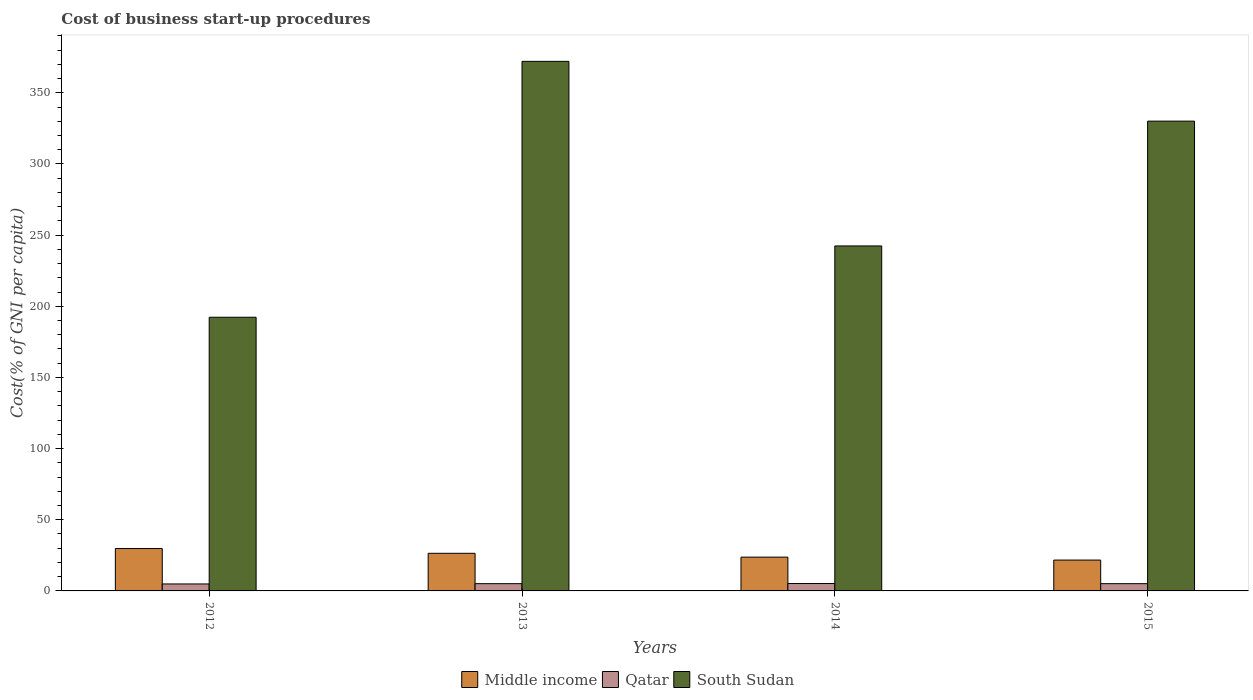How many groups of bars are there?
Your answer should be compact. 4. Are the number of bars per tick equal to the number of legend labels?
Your answer should be compact. Yes. Are the number of bars on each tick of the X-axis equal?
Your response must be concise. Yes. How many bars are there on the 3rd tick from the right?
Your answer should be compact. 3. What is the label of the 4th group of bars from the left?
Ensure brevity in your answer.  2015. In how many cases, is the number of bars for a given year not equal to the number of legend labels?
Offer a terse response. 0. What is the cost of business start-up procedures in South Sudan in 2013?
Provide a succinct answer. 372.1. Across all years, what is the maximum cost of business start-up procedures in Middle income?
Your answer should be very brief. 29.78. Across all years, what is the minimum cost of business start-up procedures in Qatar?
Give a very brief answer. 4.9. In which year was the cost of business start-up procedures in Middle income minimum?
Make the answer very short. 2015. What is the total cost of business start-up procedures in Qatar in the graph?
Keep it short and to the point. 20.3. What is the difference between the cost of business start-up procedures in South Sudan in 2012 and that in 2015?
Provide a short and direct response. -137.8. What is the difference between the cost of business start-up procedures in Qatar in 2015 and the cost of business start-up procedures in Middle income in 2012?
Provide a succinct answer. -24.68. What is the average cost of business start-up procedures in Middle income per year?
Give a very brief answer. 25.41. In the year 2012, what is the difference between the cost of business start-up procedures in Middle income and cost of business start-up procedures in Qatar?
Offer a terse response. 24.88. What is the ratio of the cost of business start-up procedures in South Sudan in 2013 to that in 2014?
Your answer should be very brief. 1.54. Is the cost of business start-up procedures in South Sudan in 2012 less than that in 2015?
Your answer should be very brief. Yes. What is the difference between the highest and the second highest cost of business start-up procedures in South Sudan?
Your response must be concise. 42. What is the difference between the highest and the lowest cost of business start-up procedures in South Sudan?
Offer a terse response. 179.8. In how many years, is the cost of business start-up procedures in Qatar greater than the average cost of business start-up procedures in Qatar taken over all years?
Give a very brief answer. 3. Is the sum of the cost of business start-up procedures in Middle income in 2012 and 2013 greater than the maximum cost of business start-up procedures in South Sudan across all years?
Make the answer very short. No. What does the 1st bar from the left in 2014 represents?
Offer a terse response. Middle income. What does the 1st bar from the right in 2015 represents?
Give a very brief answer. South Sudan. Are all the bars in the graph horizontal?
Your answer should be very brief. No. How many years are there in the graph?
Offer a terse response. 4. Are the values on the major ticks of Y-axis written in scientific E-notation?
Your answer should be very brief. No. Does the graph contain any zero values?
Make the answer very short. No. Does the graph contain grids?
Keep it short and to the point. No. How are the legend labels stacked?
Provide a succinct answer. Horizontal. What is the title of the graph?
Provide a short and direct response. Cost of business start-up procedures. What is the label or title of the X-axis?
Keep it short and to the point. Years. What is the label or title of the Y-axis?
Ensure brevity in your answer.  Cost(% of GNI per capita). What is the Cost(% of GNI per capita) in Middle income in 2012?
Ensure brevity in your answer.  29.78. What is the Cost(% of GNI per capita) of Qatar in 2012?
Offer a terse response. 4.9. What is the Cost(% of GNI per capita) of South Sudan in 2012?
Offer a very short reply. 192.3. What is the Cost(% of GNI per capita) in Middle income in 2013?
Ensure brevity in your answer.  26.43. What is the Cost(% of GNI per capita) in South Sudan in 2013?
Provide a succinct answer. 372.1. What is the Cost(% of GNI per capita) in Middle income in 2014?
Keep it short and to the point. 23.74. What is the Cost(% of GNI per capita) of South Sudan in 2014?
Offer a terse response. 242.4. What is the Cost(% of GNI per capita) in Middle income in 2015?
Ensure brevity in your answer.  21.68. What is the Cost(% of GNI per capita) of Qatar in 2015?
Your answer should be compact. 5.1. What is the Cost(% of GNI per capita) in South Sudan in 2015?
Provide a succinct answer. 330.1. Across all years, what is the maximum Cost(% of GNI per capita) of Middle income?
Offer a terse response. 29.78. Across all years, what is the maximum Cost(% of GNI per capita) in South Sudan?
Provide a short and direct response. 372.1. Across all years, what is the minimum Cost(% of GNI per capita) in Middle income?
Your response must be concise. 21.68. Across all years, what is the minimum Cost(% of GNI per capita) of Qatar?
Provide a short and direct response. 4.9. Across all years, what is the minimum Cost(% of GNI per capita) of South Sudan?
Offer a very short reply. 192.3. What is the total Cost(% of GNI per capita) in Middle income in the graph?
Your response must be concise. 101.62. What is the total Cost(% of GNI per capita) of Qatar in the graph?
Your answer should be compact. 20.3. What is the total Cost(% of GNI per capita) in South Sudan in the graph?
Provide a succinct answer. 1136.9. What is the difference between the Cost(% of GNI per capita) of Middle income in 2012 and that in 2013?
Your answer should be very brief. 3.36. What is the difference between the Cost(% of GNI per capita) in Qatar in 2012 and that in 2013?
Give a very brief answer. -0.2. What is the difference between the Cost(% of GNI per capita) of South Sudan in 2012 and that in 2013?
Your response must be concise. -179.8. What is the difference between the Cost(% of GNI per capita) in Middle income in 2012 and that in 2014?
Provide a succinct answer. 6.04. What is the difference between the Cost(% of GNI per capita) in Qatar in 2012 and that in 2014?
Offer a very short reply. -0.3. What is the difference between the Cost(% of GNI per capita) of South Sudan in 2012 and that in 2014?
Your response must be concise. -50.1. What is the difference between the Cost(% of GNI per capita) in Middle income in 2012 and that in 2015?
Make the answer very short. 8.11. What is the difference between the Cost(% of GNI per capita) in Qatar in 2012 and that in 2015?
Your response must be concise. -0.2. What is the difference between the Cost(% of GNI per capita) of South Sudan in 2012 and that in 2015?
Make the answer very short. -137.8. What is the difference between the Cost(% of GNI per capita) in Middle income in 2013 and that in 2014?
Ensure brevity in your answer.  2.69. What is the difference between the Cost(% of GNI per capita) in Qatar in 2013 and that in 2014?
Your answer should be very brief. -0.1. What is the difference between the Cost(% of GNI per capita) in South Sudan in 2013 and that in 2014?
Your answer should be compact. 129.7. What is the difference between the Cost(% of GNI per capita) of Middle income in 2013 and that in 2015?
Your answer should be compact. 4.75. What is the difference between the Cost(% of GNI per capita) of Qatar in 2013 and that in 2015?
Your response must be concise. 0. What is the difference between the Cost(% of GNI per capita) in South Sudan in 2013 and that in 2015?
Offer a terse response. 42. What is the difference between the Cost(% of GNI per capita) of Middle income in 2014 and that in 2015?
Your response must be concise. 2.06. What is the difference between the Cost(% of GNI per capita) of Qatar in 2014 and that in 2015?
Offer a very short reply. 0.1. What is the difference between the Cost(% of GNI per capita) of South Sudan in 2014 and that in 2015?
Make the answer very short. -87.7. What is the difference between the Cost(% of GNI per capita) in Middle income in 2012 and the Cost(% of GNI per capita) in Qatar in 2013?
Give a very brief answer. 24.68. What is the difference between the Cost(% of GNI per capita) in Middle income in 2012 and the Cost(% of GNI per capita) in South Sudan in 2013?
Your answer should be compact. -342.32. What is the difference between the Cost(% of GNI per capita) in Qatar in 2012 and the Cost(% of GNI per capita) in South Sudan in 2013?
Give a very brief answer. -367.2. What is the difference between the Cost(% of GNI per capita) of Middle income in 2012 and the Cost(% of GNI per capita) of Qatar in 2014?
Provide a succinct answer. 24.58. What is the difference between the Cost(% of GNI per capita) in Middle income in 2012 and the Cost(% of GNI per capita) in South Sudan in 2014?
Provide a succinct answer. -212.62. What is the difference between the Cost(% of GNI per capita) of Qatar in 2012 and the Cost(% of GNI per capita) of South Sudan in 2014?
Give a very brief answer. -237.5. What is the difference between the Cost(% of GNI per capita) of Middle income in 2012 and the Cost(% of GNI per capita) of Qatar in 2015?
Offer a very short reply. 24.68. What is the difference between the Cost(% of GNI per capita) of Middle income in 2012 and the Cost(% of GNI per capita) of South Sudan in 2015?
Provide a short and direct response. -300.32. What is the difference between the Cost(% of GNI per capita) in Qatar in 2012 and the Cost(% of GNI per capita) in South Sudan in 2015?
Offer a very short reply. -325.2. What is the difference between the Cost(% of GNI per capita) of Middle income in 2013 and the Cost(% of GNI per capita) of Qatar in 2014?
Your answer should be compact. 21.23. What is the difference between the Cost(% of GNI per capita) of Middle income in 2013 and the Cost(% of GNI per capita) of South Sudan in 2014?
Offer a terse response. -215.97. What is the difference between the Cost(% of GNI per capita) in Qatar in 2013 and the Cost(% of GNI per capita) in South Sudan in 2014?
Make the answer very short. -237.3. What is the difference between the Cost(% of GNI per capita) in Middle income in 2013 and the Cost(% of GNI per capita) in Qatar in 2015?
Make the answer very short. 21.33. What is the difference between the Cost(% of GNI per capita) in Middle income in 2013 and the Cost(% of GNI per capita) in South Sudan in 2015?
Make the answer very short. -303.67. What is the difference between the Cost(% of GNI per capita) in Qatar in 2013 and the Cost(% of GNI per capita) in South Sudan in 2015?
Provide a succinct answer. -325. What is the difference between the Cost(% of GNI per capita) in Middle income in 2014 and the Cost(% of GNI per capita) in Qatar in 2015?
Your answer should be compact. 18.64. What is the difference between the Cost(% of GNI per capita) of Middle income in 2014 and the Cost(% of GNI per capita) of South Sudan in 2015?
Your answer should be compact. -306.36. What is the difference between the Cost(% of GNI per capita) of Qatar in 2014 and the Cost(% of GNI per capita) of South Sudan in 2015?
Offer a terse response. -324.9. What is the average Cost(% of GNI per capita) in Middle income per year?
Keep it short and to the point. 25.41. What is the average Cost(% of GNI per capita) in Qatar per year?
Your answer should be very brief. 5.08. What is the average Cost(% of GNI per capita) in South Sudan per year?
Provide a short and direct response. 284.23. In the year 2012, what is the difference between the Cost(% of GNI per capita) in Middle income and Cost(% of GNI per capita) in Qatar?
Offer a terse response. 24.88. In the year 2012, what is the difference between the Cost(% of GNI per capita) in Middle income and Cost(% of GNI per capita) in South Sudan?
Ensure brevity in your answer.  -162.52. In the year 2012, what is the difference between the Cost(% of GNI per capita) in Qatar and Cost(% of GNI per capita) in South Sudan?
Offer a very short reply. -187.4. In the year 2013, what is the difference between the Cost(% of GNI per capita) in Middle income and Cost(% of GNI per capita) in Qatar?
Keep it short and to the point. 21.33. In the year 2013, what is the difference between the Cost(% of GNI per capita) in Middle income and Cost(% of GNI per capita) in South Sudan?
Offer a terse response. -345.67. In the year 2013, what is the difference between the Cost(% of GNI per capita) of Qatar and Cost(% of GNI per capita) of South Sudan?
Make the answer very short. -367. In the year 2014, what is the difference between the Cost(% of GNI per capita) in Middle income and Cost(% of GNI per capita) in Qatar?
Keep it short and to the point. 18.54. In the year 2014, what is the difference between the Cost(% of GNI per capita) of Middle income and Cost(% of GNI per capita) of South Sudan?
Your answer should be compact. -218.66. In the year 2014, what is the difference between the Cost(% of GNI per capita) in Qatar and Cost(% of GNI per capita) in South Sudan?
Your answer should be compact. -237.2. In the year 2015, what is the difference between the Cost(% of GNI per capita) of Middle income and Cost(% of GNI per capita) of Qatar?
Make the answer very short. 16.58. In the year 2015, what is the difference between the Cost(% of GNI per capita) of Middle income and Cost(% of GNI per capita) of South Sudan?
Make the answer very short. -308.42. In the year 2015, what is the difference between the Cost(% of GNI per capita) of Qatar and Cost(% of GNI per capita) of South Sudan?
Give a very brief answer. -325. What is the ratio of the Cost(% of GNI per capita) of Middle income in 2012 to that in 2013?
Provide a short and direct response. 1.13. What is the ratio of the Cost(% of GNI per capita) in Qatar in 2012 to that in 2013?
Your answer should be very brief. 0.96. What is the ratio of the Cost(% of GNI per capita) in South Sudan in 2012 to that in 2013?
Make the answer very short. 0.52. What is the ratio of the Cost(% of GNI per capita) in Middle income in 2012 to that in 2014?
Your answer should be compact. 1.25. What is the ratio of the Cost(% of GNI per capita) of Qatar in 2012 to that in 2014?
Offer a very short reply. 0.94. What is the ratio of the Cost(% of GNI per capita) of South Sudan in 2012 to that in 2014?
Keep it short and to the point. 0.79. What is the ratio of the Cost(% of GNI per capita) of Middle income in 2012 to that in 2015?
Your answer should be very brief. 1.37. What is the ratio of the Cost(% of GNI per capita) of Qatar in 2012 to that in 2015?
Provide a short and direct response. 0.96. What is the ratio of the Cost(% of GNI per capita) in South Sudan in 2012 to that in 2015?
Make the answer very short. 0.58. What is the ratio of the Cost(% of GNI per capita) in Middle income in 2013 to that in 2014?
Provide a succinct answer. 1.11. What is the ratio of the Cost(% of GNI per capita) in Qatar in 2013 to that in 2014?
Make the answer very short. 0.98. What is the ratio of the Cost(% of GNI per capita) in South Sudan in 2013 to that in 2014?
Offer a very short reply. 1.54. What is the ratio of the Cost(% of GNI per capita) in Middle income in 2013 to that in 2015?
Your answer should be compact. 1.22. What is the ratio of the Cost(% of GNI per capita) of Qatar in 2013 to that in 2015?
Your answer should be compact. 1. What is the ratio of the Cost(% of GNI per capita) of South Sudan in 2013 to that in 2015?
Your answer should be very brief. 1.13. What is the ratio of the Cost(% of GNI per capita) in Middle income in 2014 to that in 2015?
Your response must be concise. 1.1. What is the ratio of the Cost(% of GNI per capita) of Qatar in 2014 to that in 2015?
Your answer should be compact. 1.02. What is the ratio of the Cost(% of GNI per capita) of South Sudan in 2014 to that in 2015?
Your answer should be very brief. 0.73. What is the difference between the highest and the second highest Cost(% of GNI per capita) in Middle income?
Your answer should be compact. 3.36. What is the difference between the highest and the second highest Cost(% of GNI per capita) in Qatar?
Your response must be concise. 0.1. What is the difference between the highest and the second highest Cost(% of GNI per capita) in South Sudan?
Provide a succinct answer. 42. What is the difference between the highest and the lowest Cost(% of GNI per capita) of Middle income?
Ensure brevity in your answer.  8.11. What is the difference between the highest and the lowest Cost(% of GNI per capita) in Qatar?
Offer a very short reply. 0.3. What is the difference between the highest and the lowest Cost(% of GNI per capita) in South Sudan?
Offer a very short reply. 179.8. 